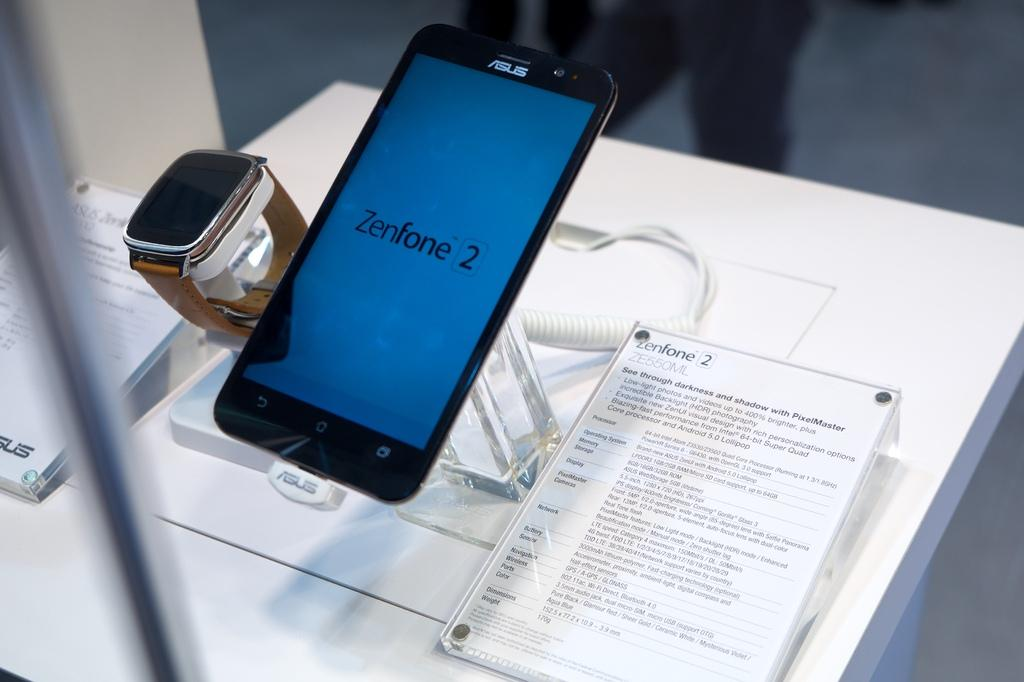<image>
Provide a brief description of the given image. ASUS phone on display at a store with a smart watch next to it. 